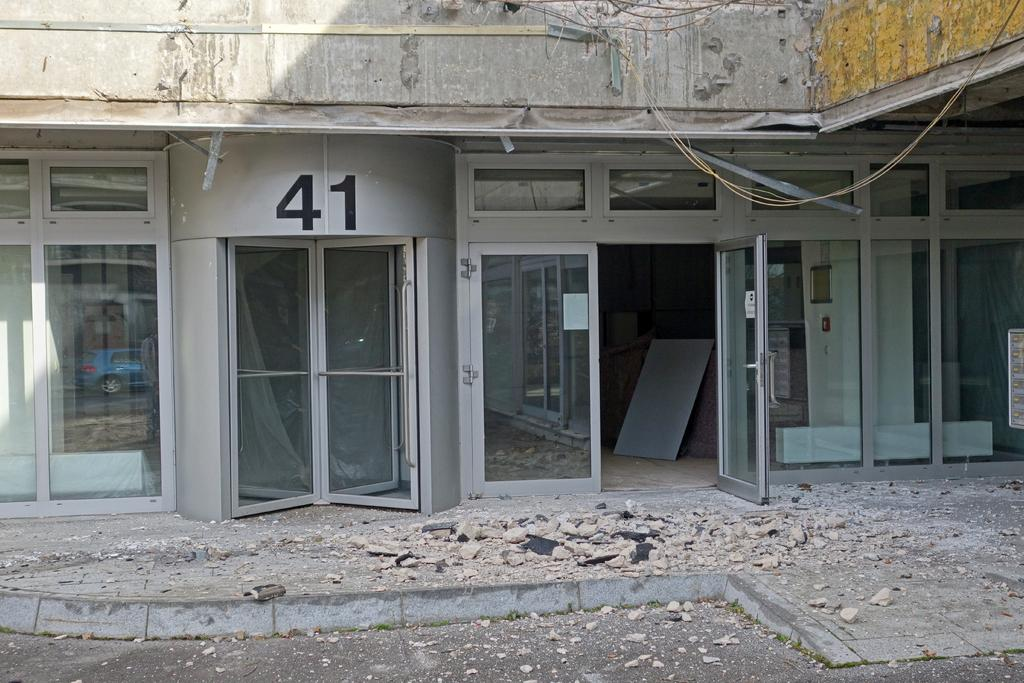What type of structure is visible in the image? There is a building in the image. What can be used to enter or exit the building? There are doors in the image. What material is used for the construction of the building? There are boards and stones in the image, which might be used for construction. What type of sorting technique is being used in the image? There is no sorting technique visible in the image. What type of plough can be seen in the image? There is no plough present in the image. 